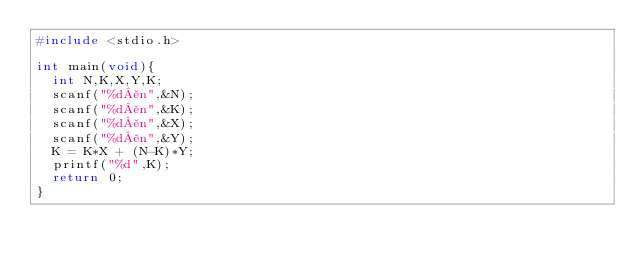Convert code to text. <code><loc_0><loc_0><loc_500><loc_500><_C_>#include <stdio.h>

int main(void){
  int N,K,X,Y,K;
  scanf("%d¥n",&N);
  scanf("%d¥n",&K);
  scanf("%d¥n",&X);
  scanf("%d¥n",&Y);
  K = K*X + (N-K)*Y;
  printf("%d",K);
  return 0;
}
  </code> 